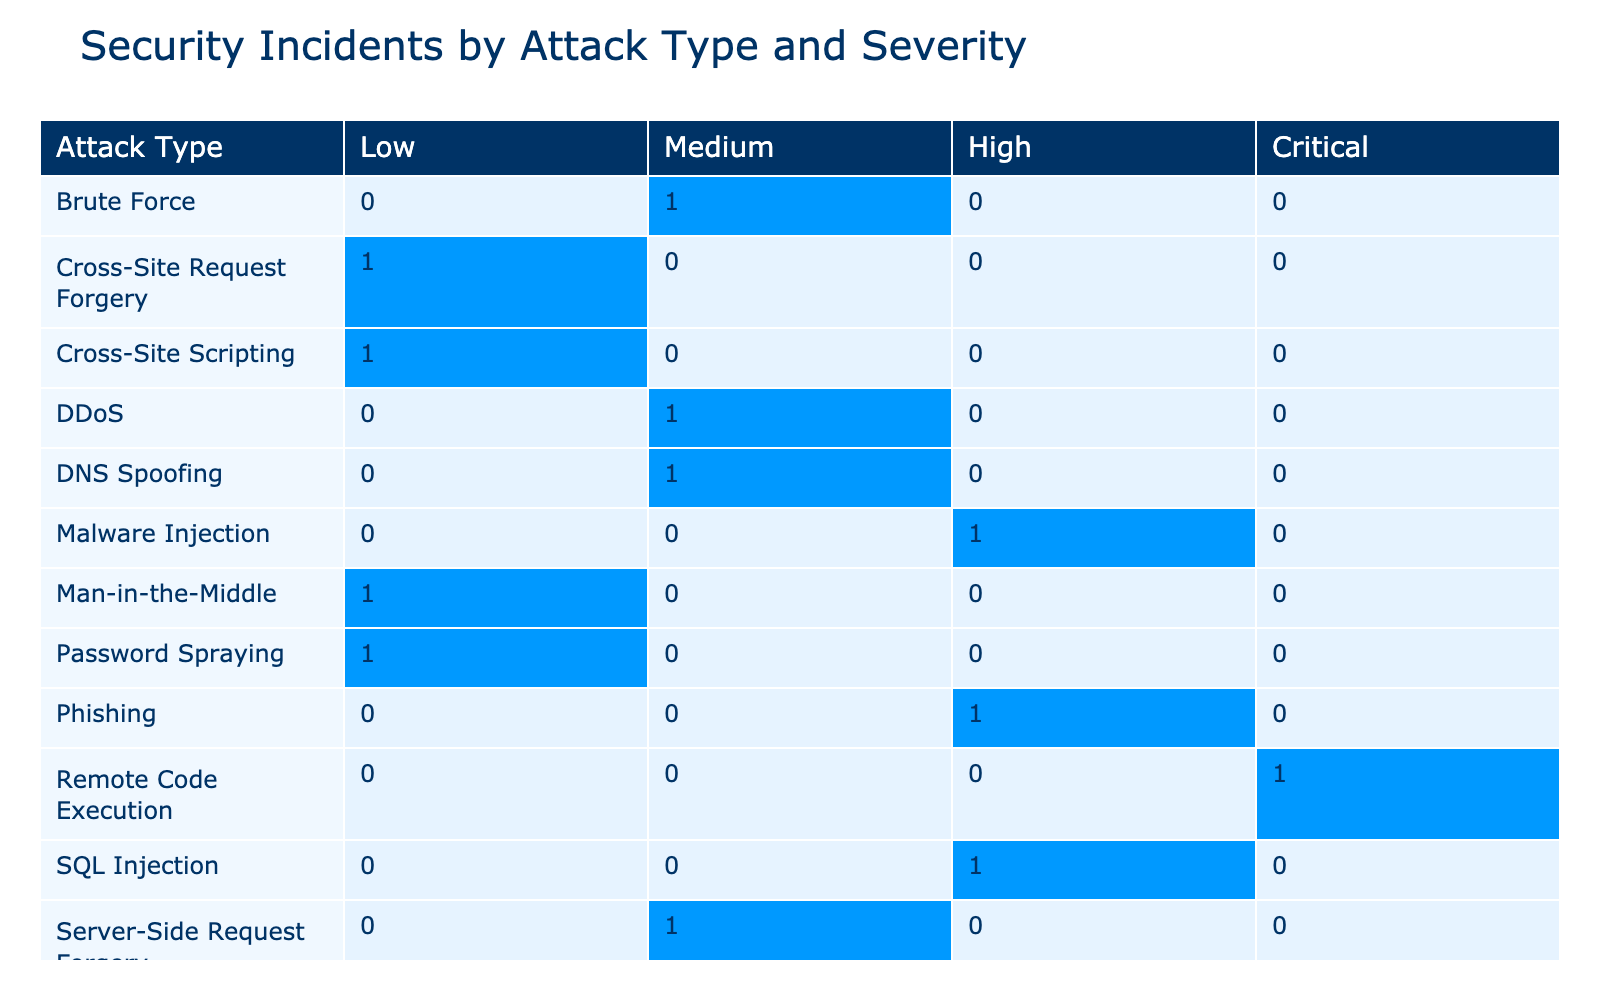What is the number of SQL Injection incidents categorized as High severity? According to the table, there is only one incident with the Attack Type of SQL Injection and a Severity of High, which is Incident ID 1.
Answer: 1 What is the total number of DDoS incidents recorded in the table? To find the total number of DDoS incidents, we can look for occurrences of DDoS in the Attack Type column. There is only one DDoS incident, which is Incident ID 2.
Answer: 1 How many incidents of Remote Code Execution are categorized as Critical severity? Referring to the table, there is one entry for Remote Code Execution under Critical severity, which is Incident ID 11.
Answer: 1 What is the total duration of all incidents classified under Medium severity? For Medium severity, the incidents are: DDoS (5.2 hours), Brute Force (4.1 hours), Session Hijacking (2.9 hours), and Server-Side Request Forgery (3.7 hours). Adding these gives 5.2 + 4.1 + 2.9 + 3.7 = 16.9 hours as the total duration.
Answer: 16.9 Is there any incident marked as resolved where the severity level is Low? By checking the table for incidents that are Low severity and the Resolved column, we find that there are two incidents: Cross-Site Scripting (Incident ID 3) and Password Spraying (Incident ID 14). Both are marked as Yes under the Resolved column, indicating they were resolved.
Answer: Yes How many incidents caused by Phishing are unresolved? There is one incident under Phishing (Incident ID 5), and it is categorized as unresolved (No under Resolved). Thus, the total number of unresolved Phishing incidents is 1.
Answer: 1 What is the difference in the number of incidents categorized as High severity versus Critical severity? The table shows that there are 4 incidents with High severity and 2 incidents with Critical severity. The difference is 4 - 2 = 2, indicating that there are 2 more incidents categorized as High severity.
Answer: 2 Which attack type has the highest count of incidents at Low severity? Upon reviewing the table for the Low severity column, we see that Cross-Site Scripting (1 incident) and Password Spraying (1 incident) are tied for the highest count at Low severity. Both have the same number of incidents, which is 1.
Answer: Cross-Site Scripting and Password Spraying How many attack types had incidents where data was compromised? Looking at the data, the attack types that resulted in compromised data (marked as Yes in the Data Compromised column) are SQL Injection, Brute Force, Phishing, Zero-Day Exploit, Malware Injection, Remote Code Execution, XML External Entity, making a total of 7 unique attack types.
Answer: 7 